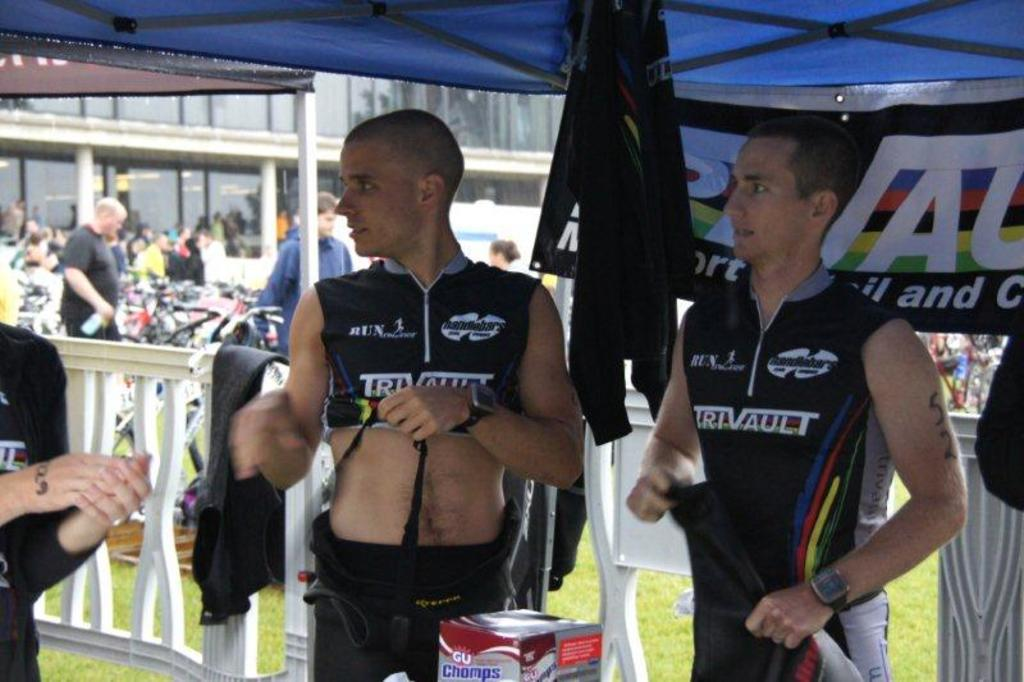Provide a one-sentence caption for the provided image. two guys wearing truvault jerseys under a blue canopy. 